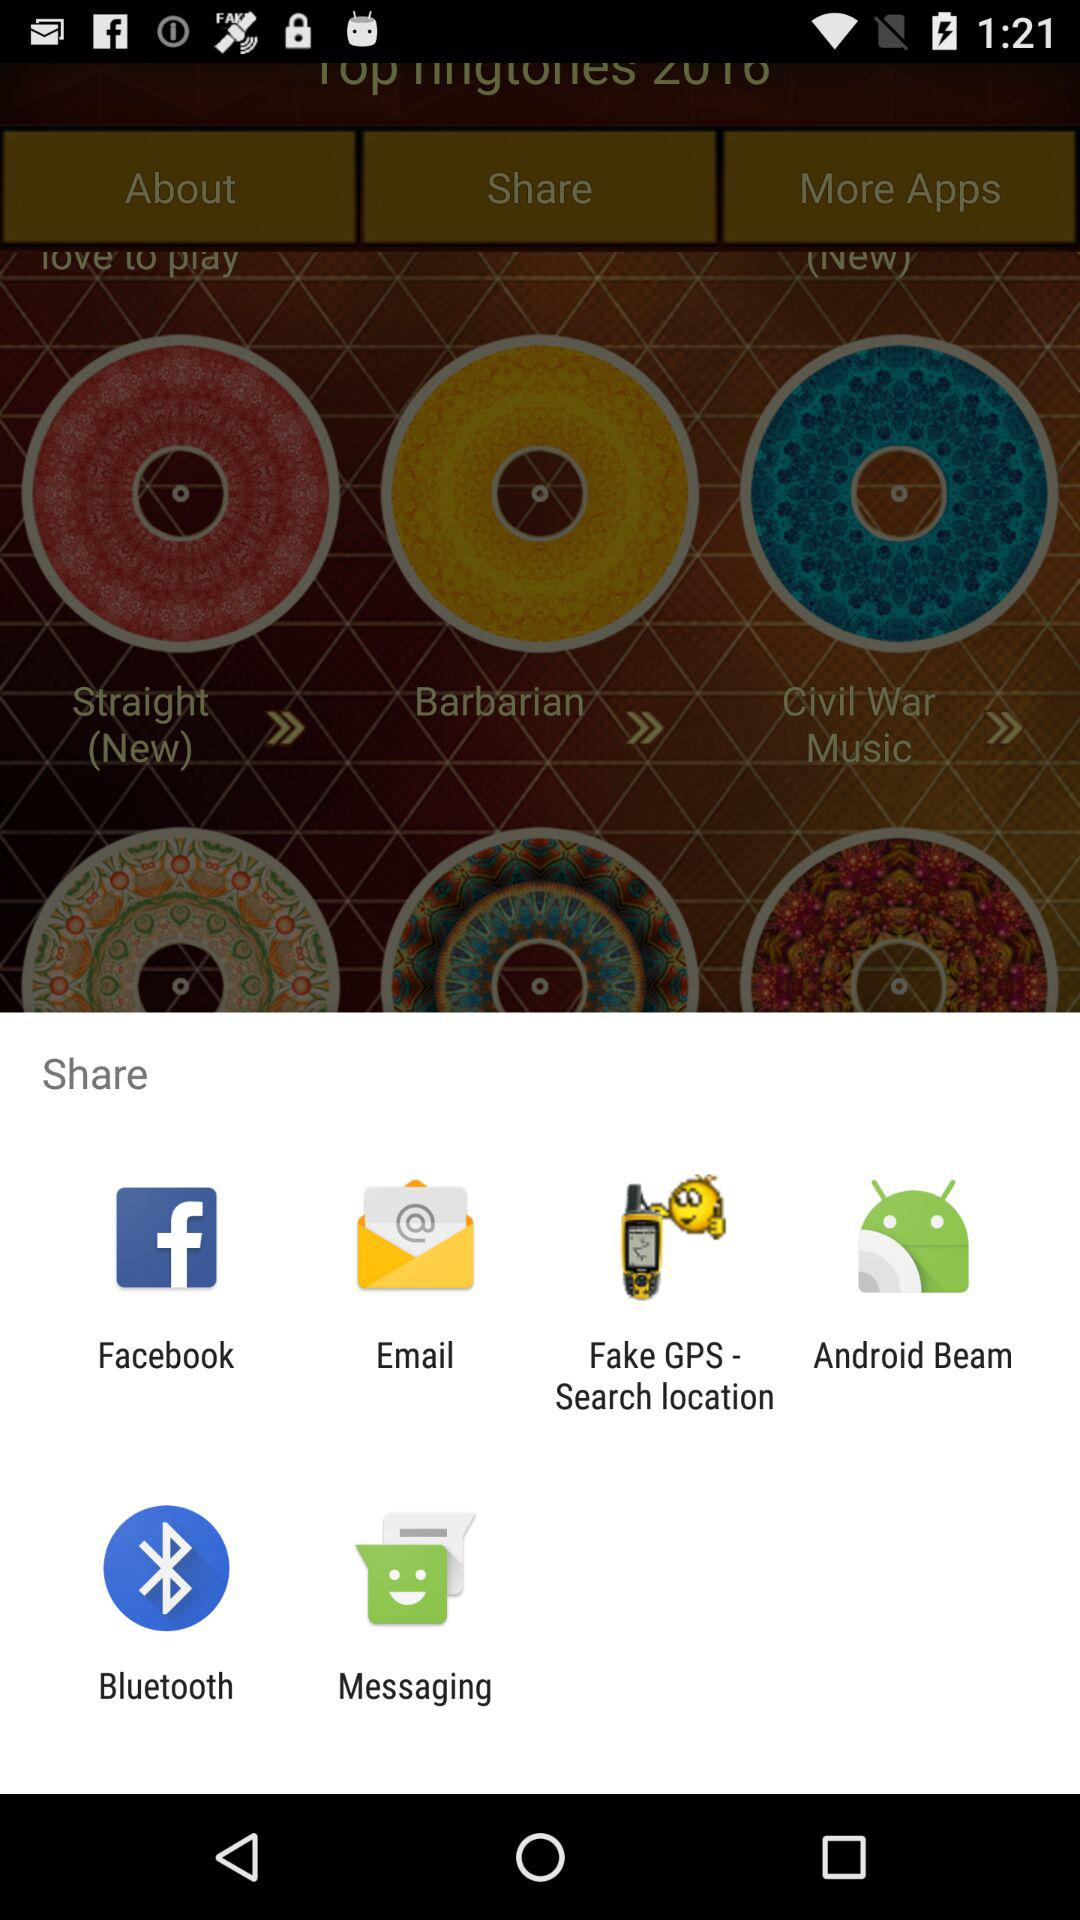Through what applications can we share? You can share with "Facebook", "Email", "Fake GPS - Search location", "Android Beam", "Bluetooth" and "Messaging". 